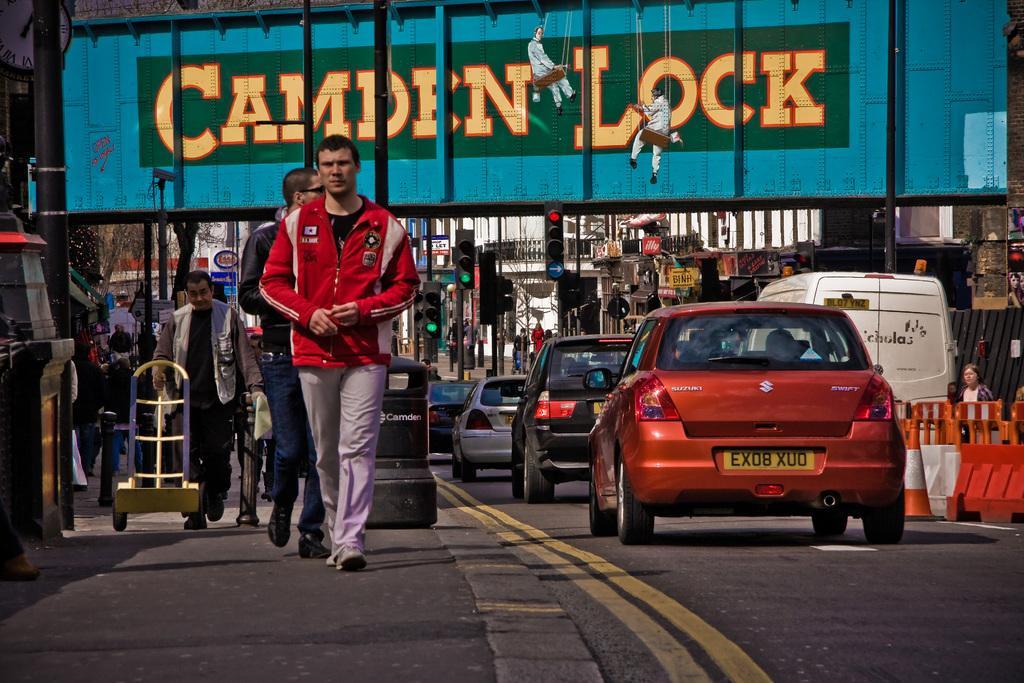Could you give a brief overview of what you see in this image? On the left there are few people walking on the road. In the background there are poles,traffic signal poles,hoardings,buildings,vehicles on the road,traffic cones,divider,trolley. In the background we can see few people also. 